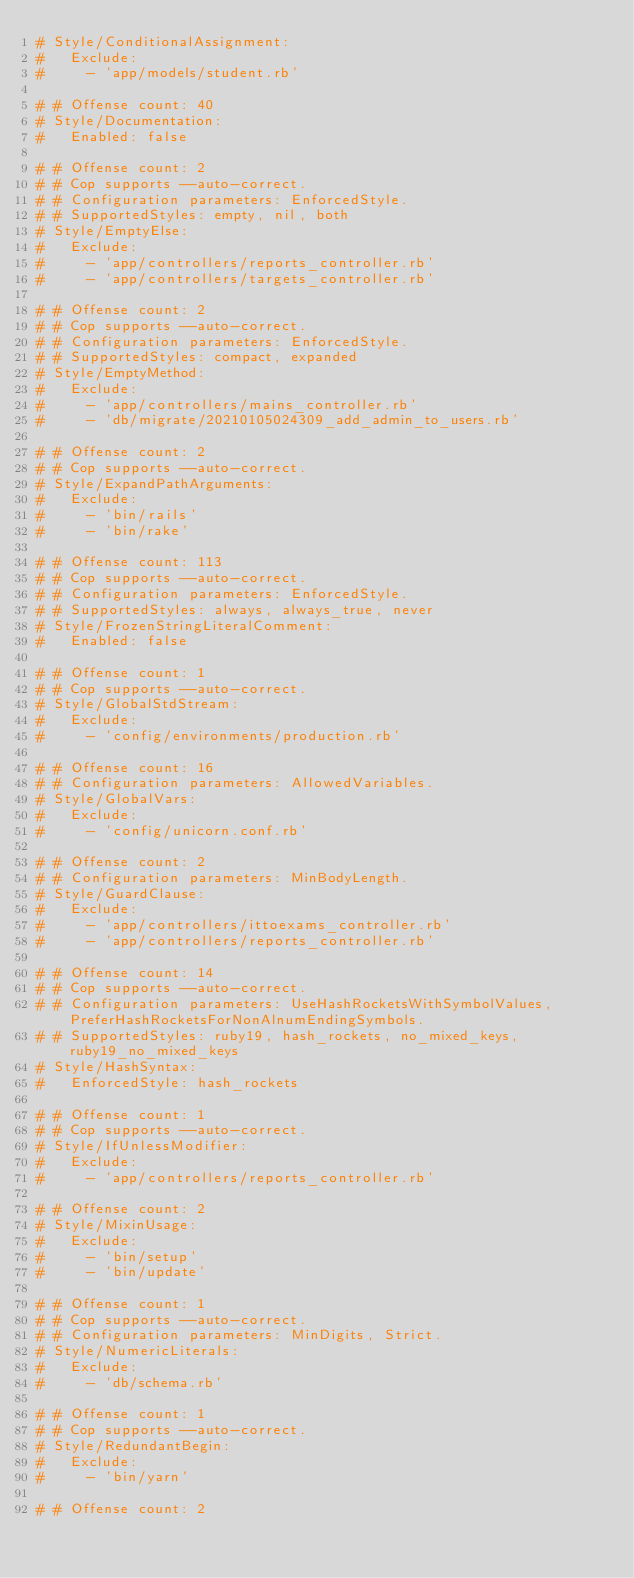Convert code to text. <code><loc_0><loc_0><loc_500><loc_500><_YAML_># Style/ConditionalAssignment:
#   Exclude:
#     - 'app/models/student.rb'

# # Offense count: 40
# Style/Documentation:
#   Enabled: false

# # Offense count: 2
# # Cop supports --auto-correct.
# # Configuration parameters: EnforcedStyle.
# # SupportedStyles: empty, nil, both
# Style/EmptyElse:
#   Exclude:
#     - 'app/controllers/reports_controller.rb'
#     - 'app/controllers/targets_controller.rb'

# # Offense count: 2
# # Cop supports --auto-correct.
# # Configuration parameters: EnforcedStyle.
# # SupportedStyles: compact, expanded
# Style/EmptyMethod:
#   Exclude:
#     - 'app/controllers/mains_controller.rb'
#     - 'db/migrate/20210105024309_add_admin_to_users.rb'

# # Offense count: 2
# # Cop supports --auto-correct.
# Style/ExpandPathArguments:
#   Exclude:
#     - 'bin/rails'
#     - 'bin/rake'

# # Offense count: 113
# # Cop supports --auto-correct.
# # Configuration parameters: EnforcedStyle.
# # SupportedStyles: always, always_true, never
# Style/FrozenStringLiteralComment:
#   Enabled: false

# # Offense count: 1
# # Cop supports --auto-correct.
# Style/GlobalStdStream:
#   Exclude:
#     - 'config/environments/production.rb'

# # Offense count: 16
# # Configuration parameters: AllowedVariables.
# Style/GlobalVars:
#   Exclude:
#     - 'config/unicorn.conf.rb'

# # Offense count: 2
# # Configuration parameters: MinBodyLength.
# Style/GuardClause:
#   Exclude:
#     - 'app/controllers/ittoexams_controller.rb'
#     - 'app/controllers/reports_controller.rb'

# # Offense count: 14
# # Cop supports --auto-correct.
# # Configuration parameters: UseHashRocketsWithSymbolValues, PreferHashRocketsForNonAlnumEndingSymbols.
# # SupportedStyles: ruby19, hash_rockets, no_mixed_keys, ruby19_no_mixed_keys
# Style/HashSyntax:
#   EnforcedStyle: hash_rockets

# # Offense count: 1
# # Cop supports --auto-correct.
# Style/IfUnlessModifier:
#   Exclude:
#     - 'app/controllers/reports_controller.rb'

# # Offense count: 2
# Style/MixinUsage:
#   Exclude:
#     - 'bin/setup'
#     - 'bin/update'

# # Offense count: 1
# # Cop supports --auto-correct.
# # Configuration parameters: MinDigits, Strict.
# Style/NumericLiterals:
#   Exclude:
#     - 'db/schema.rb'

# # Offense count: 1
# # Cop supports --auto-correct.
# Style/RedundantBegin:
#   Exclude:
#     - 'bin/yarn'

# # Offense count: 2</code> 